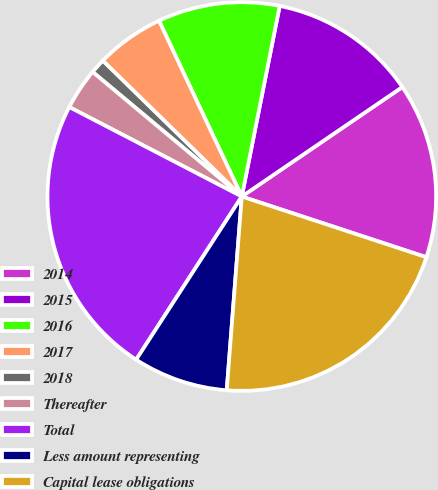Convert chart to OTSL. <chart><loc_0><loc_0><loc_500><loc_500><pie_chart><fcel>2014<fcel>2015<fcel>2016<fcel>2017<fcel>2018<fcel>Thereafter<fcel>Total<fcel>Less amount representing<fcel>Capital lease obligations<nl><fcel>14.58%<fcel>12.35%<fcel>10.13%<fcel>5.68%<fcel>1.24%<fcel>3.46%<fcel>23.47%<fcel>7.91%<fcel>21.18%<nl></chart> 